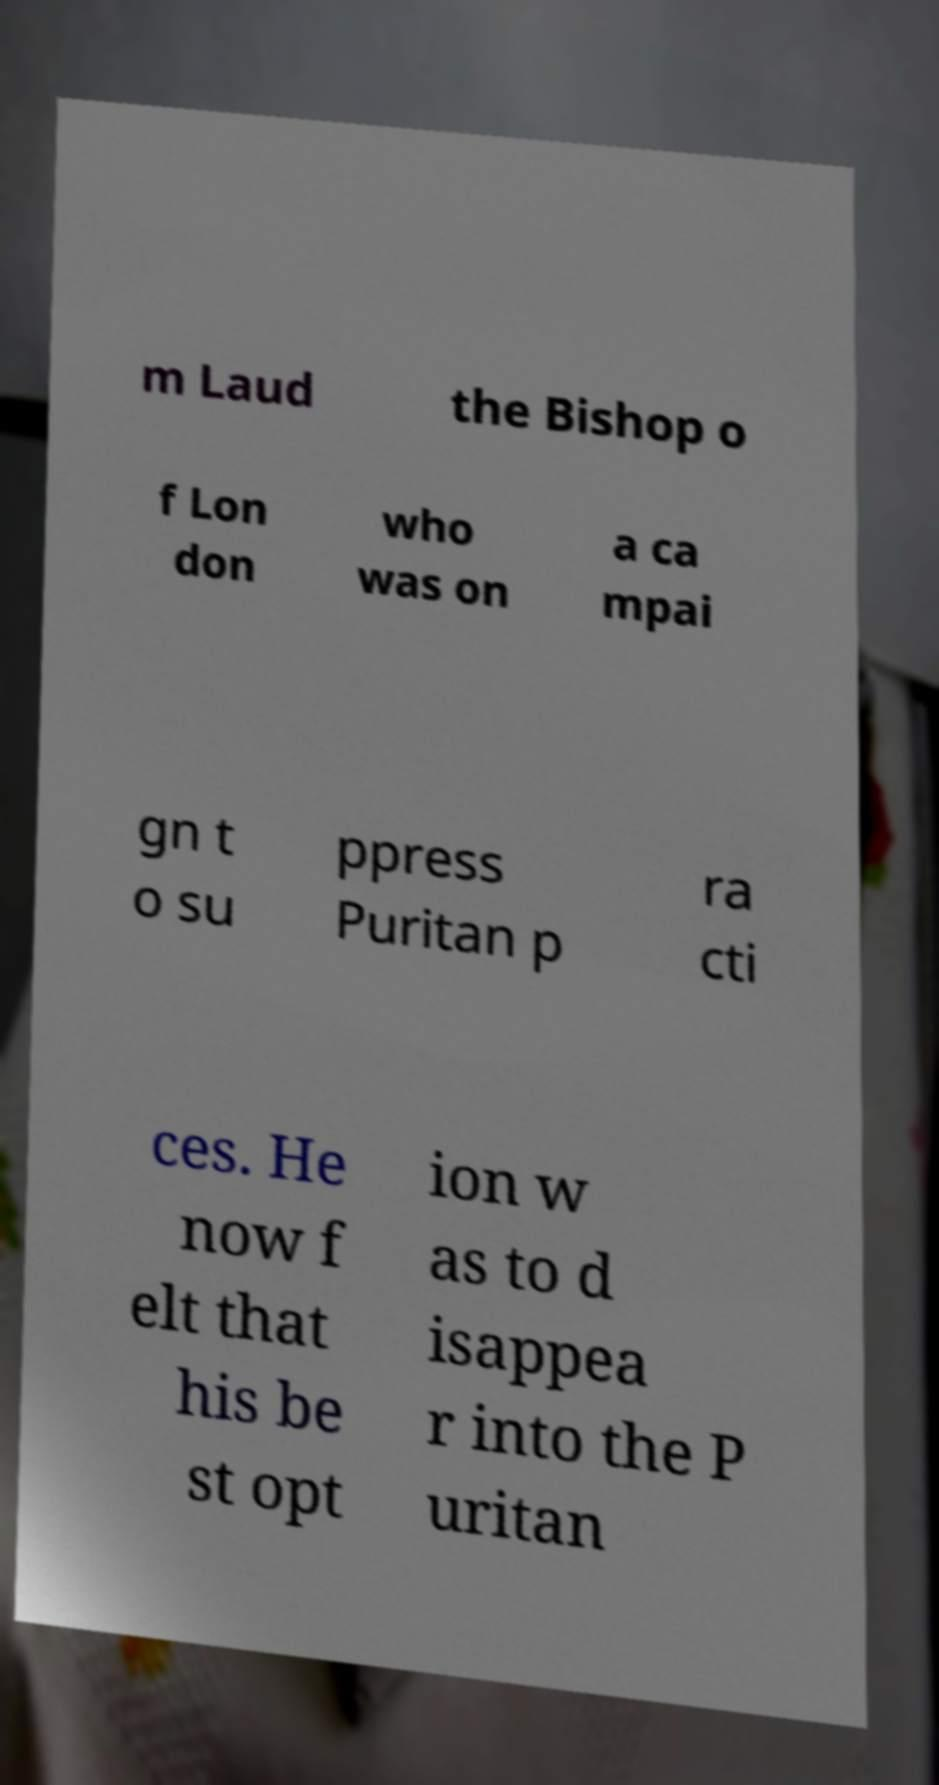Can you read and provide the text displayed in the image?This photo seems to have some interesting text. Can you extract and type it out for me? m Laud the Bishop o f Lon don who was on a ca mpai gn t o su ppress Puritan p ra cti ces. He now f elt that his be st opt ion w as to d isappea r into the P uritan 